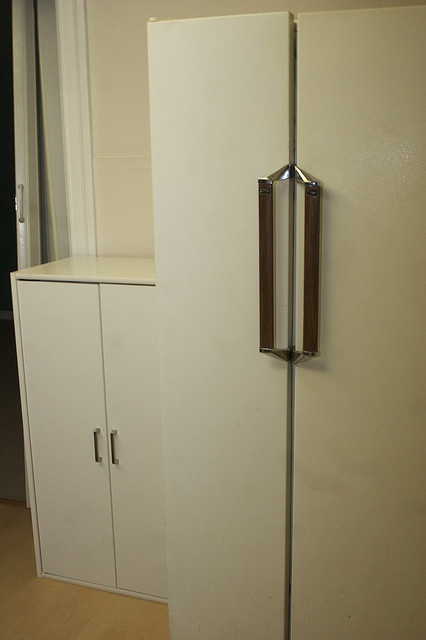Describe the objects in this image and their specific colors. I can see a refrigerator in black, gray, and tan tones in this image. 